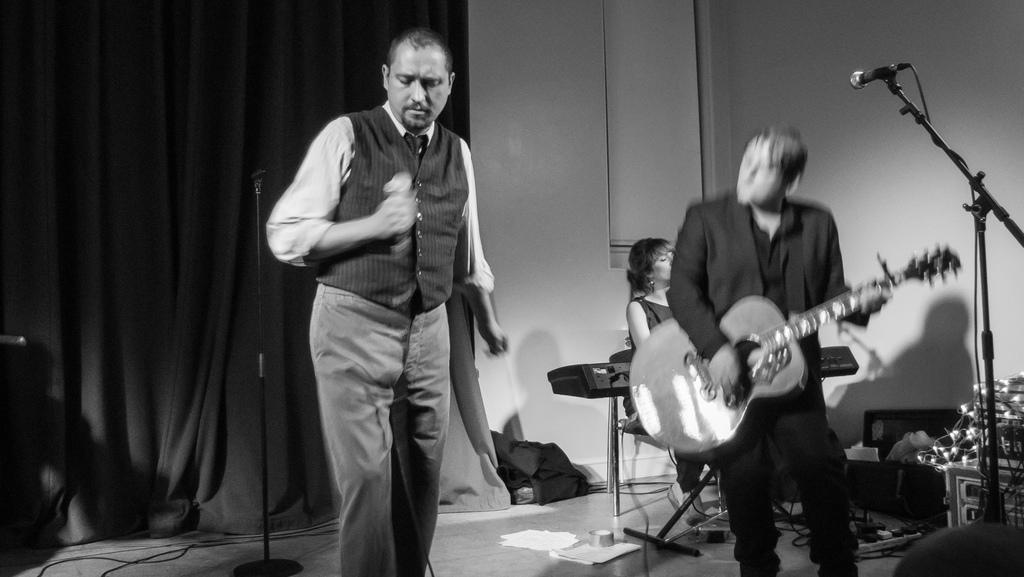What are the two men doing on stage? The two men are playing guitars on stage. What is the men's position in relation to the microphone? The men are in front of a microphone. What instrument is the woman playing in the image? The woman is playing a piano in the image. Where is the woman positioned in relation to the men? The woman is at the back of the men. What type of hat is the woman wearing while playing the piano? There is no hat visible in the image; the woman is not wearing a hat while playing the piano. 